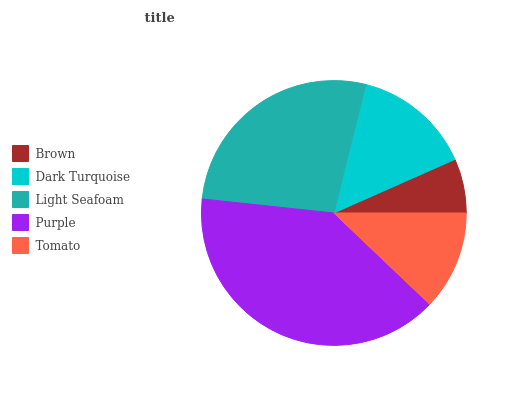Is Brown the minimum?
Answer yes or no. Yes. Is Purple the maximum?
Answer yes or no. Yes. Is Dark Turquoise the minimum?
Answer yes or no. No. Is Dark Turquoise the maximum?
Answer yes or no. No. Is Dark Turquoise greater than Brown?
Answer yes or no. Yes. Is Brown less than Dark Turquoise?
Answer yes or no. Yes. Is Brown greater than Dark Turquoise?
Answer yes or no. No. Is Dark Turquoise less than Brown?
Answer yes or no. No. Is Dark Turquoise the high median?
Answer yes or no. Yes. Is Dark Turquoise the low median?
Answer yes or no. Yes. Is Brown the high median?
Answer yes or no. No. Is Light Seafoam the low median?
Answer yes or no. No. 